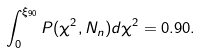<formula> <loc_0><loc_0><loc_500><loc_500>\int _ { 0 } ^ { \xi _ { 9 0 } } P ( \chi ^ { 2 } , N _ { n } ) d \chi ^ { 2 } = 0 . 9 0 .</formula> 